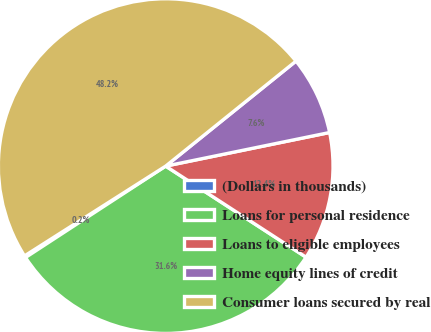Convert chart to OTSL. <chart><loc_0><loc_0><loc_500><loc_500><pie_chart><fcel>(Dollars in thousands)<fcel>Loans for personal residence<fcel>Loans to eligible employees<fcel>Home equity lines of credit<fcel>Consumer loans secured by real<nl><fcel>0.18%<fcel>31.64%<fcel>12.38%<fcel>7.58%<fcel>48.22%<nl></chart> 